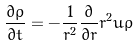Convert formula to latex. <formula><loc_0><loc_0><loc_500><loc_500>\frac { \partial \rho } { \partial t } = - \frac { 1 } { r ^ { 2 } } \frac { \partial } { \partial r } r ^ { 2 } u \rho</formula> 